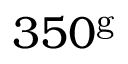<formula> <loc_0><loc_0><loc_500><loc_500>3 5 0 ^ { g }</formula> 